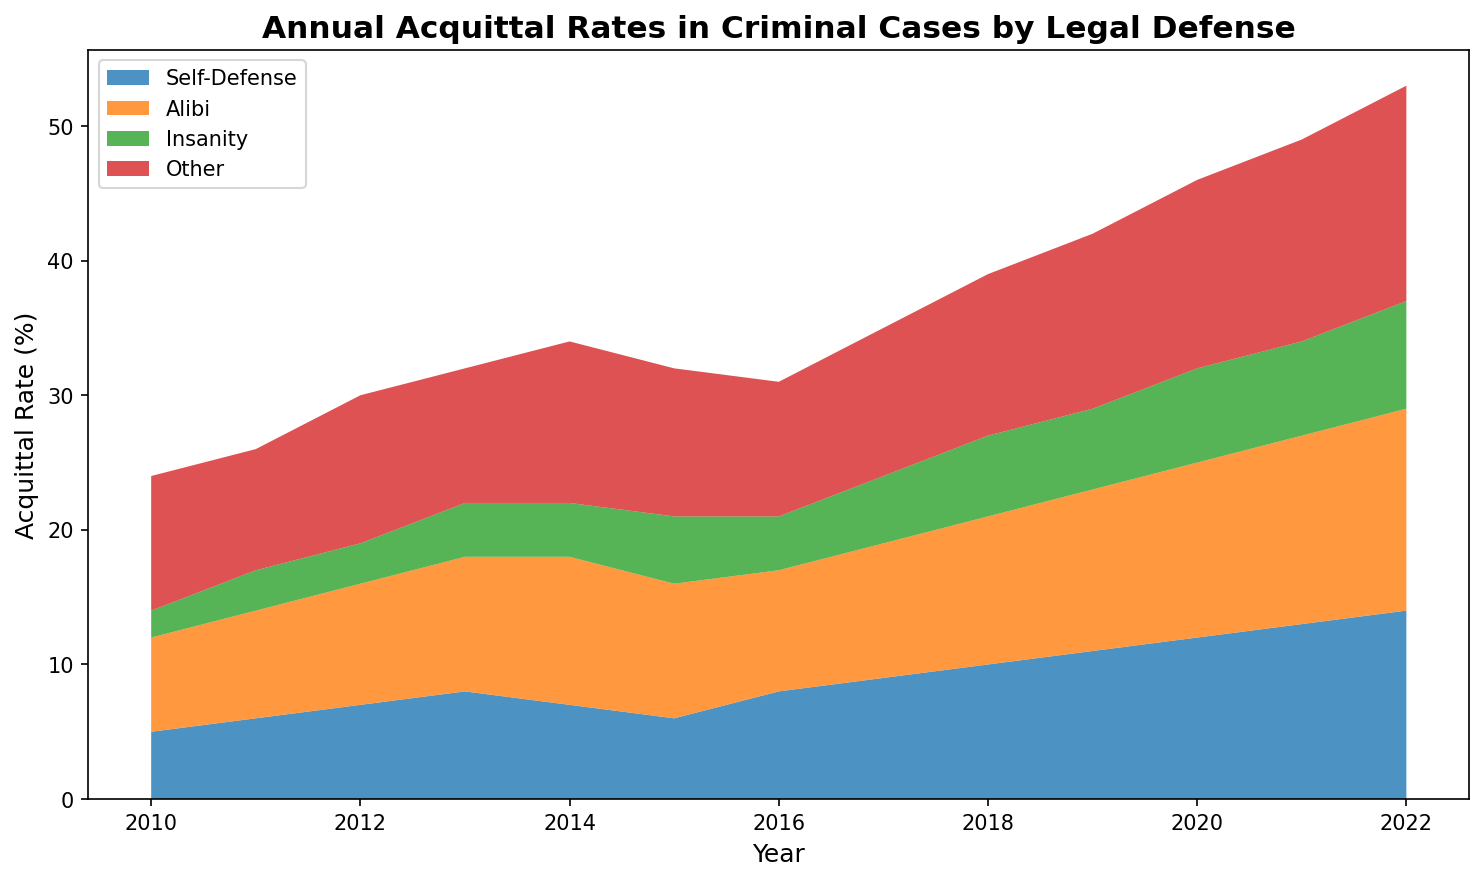Which year had the highest overall acquittal rate? To find the year with the highest overall acquittal rate, look for the year with the tallest combined 'stack' of all types of defenses in the area chart. The tallest overall stack occurs in 2022.
Answer: 2022 Between 'Self-Defense' and 'Insanity', which type of defense saw a greater increase in acquittal rates from 2010 to 2022? First, find the acquittal rates for both defenses in 2010 and 2022. Self-Defense: 14 in 2022 and 5 in 2010, which is an increase of 9. Insanity: 8 in 2022 and 2 in 2010, an increase of 6. Hence, 'Self-Defense' saw a greater increase.
Answer: Self-Defense What was the total acquittal rate across all defenses in 2015? Sum the rates for all defenses in 2015: Self-Defense (6) + Alibi (10) + Insanity (5) + Other (11). The total is 6 + 10 + 5 + 11 = 32.
Answer: 32 Did the acquittal rate for the 'Alibi' defense ever surpass the 'Other' defense? By examining the area chart, compare the heights of the sections for 'Alibi' and 'Other' across the years. 'Alibi' consistently stays below 'Other' in height throughout the observed years.
Answer: No How many years did 'Self-Defense' have higher acquittal rates than 'Insanity'? Compare the heights of the regions for 'Self-Defense' and 'Insanity' for each year from 2010 to 2022. 'Self-Defense' had higher rates in all years, making it a total of 13 years.
Answer: 13 What is the average acquittal rate for 'Other' from 2010 to 2022? To find the average, add up the 'Other' rates for all years and divide by the number of years: (10 + 9 + 11 + 10 + 12 + 11 + 10 + 11 + 12 + 13 + 14 + 15 + 16) / 13 = 155 / 13 ≈ 11.92.
Answer: 11.92 In which year were the acquittal rates for 'Self-Defense' and 'Alibi' closest to each other? Compare the differences between 'Self-Defense' and 'Alibi' each year. The smallest difference is 1 in the year 2016 with 'Self-Defense' at 8 and 'Alibi' at 9.
Answer: 2016 From 2010 to 2022, which defense had the most consistent acquittal rates without large fluctuations? Examine the areas for each defense over the years. 'Insanity' shows the least variation, maintaining steady gradual increases compared to the other defenses.
Answer: Insanity 